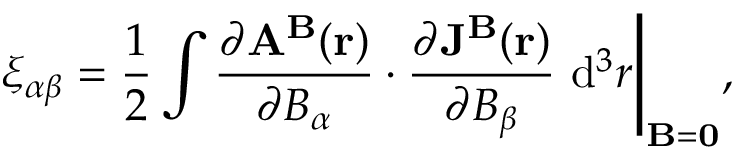<formula> <loc_0><loc_0><loc_500><loc_500>\xi _ { \alpha \beta } = \frac { 1 } { 2 } \int \frac { \partial A ^ { B } ( r ) } { \partial B _ { \alpha } } \cdot \frac { \partial J ^ { B } ( r ) } { \partial B _ { \beta } } d ^ { 3 } r \Big | _ { { B } = { 0 } } ,</formula> 